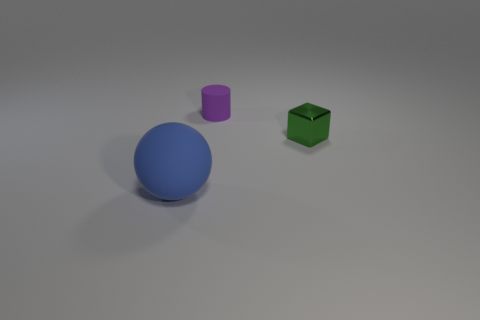Are there any other things that are the same material as the green thing?
Give a very brief answer. No. What is the color of the metallic object?
Your answer should be very brief. Green. How many rubber things are either tiny yellow cubes or tiny cylinders?
Provide a short and direct response. 1. Is there a large brown metal ball?
Keep it short and to the point. No. Is the material of the blue object that is on the left side of the tiny purple rubber cylinder the same as the object behind the green metallic block?
Provide a succinct answer. Yes. How many objects are either small things behind the small metal block or rubber objects in front of the green thing?
Give a very brief answer. 2. Do the small object that is on the left side of the small shiny block and the thing to the left of the tiny purple rubber object have the same color?
Your answer should be compact. No. The thing that is in front of the small purple rubber cylinder and on the left side of the metallic thing has what shape?
Provide a short and direct response. Sphere. What color is the cylinder that is the same size as the shiny cube?
Your answer should be compact. Purple. Are there any other large matte spheres of the same color as the ball?
Ensure brevity in your answer.  No. 